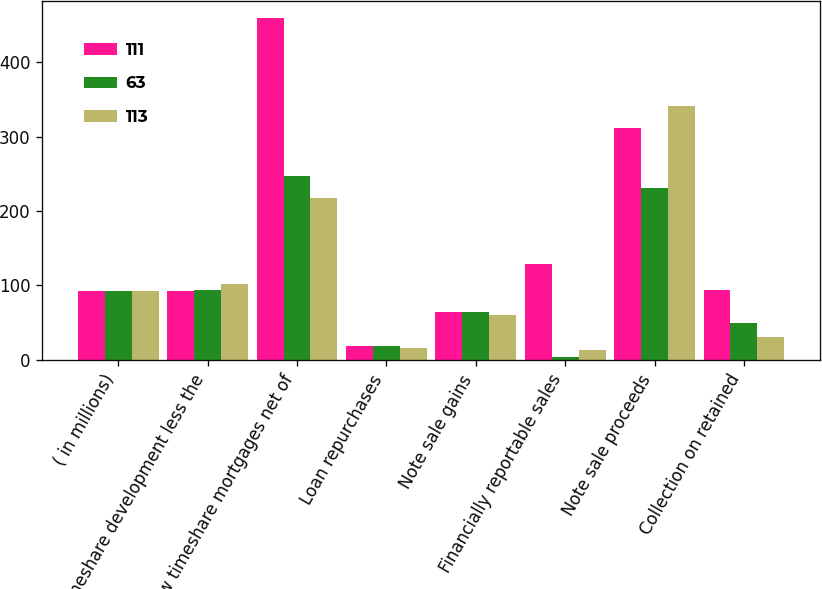Convert chart. <chart><loc_0><loc_0><loc_500><loc_500><stacked_bar_chart><ecel><fcel>( in millions)<fcel>Timeshare development less the<fcel>New timeshare mortgages net of<fcel>Loan repurchases<fcel>Note sale gains<fcel>Financially reportable sales<fcel>Note sale proceeds<fcel>Collection on retained<nl><fcel>111<fcel>93<fcel>93<fcel>459<fcel>18<fcel>64<fcel>129<fcel>312<fcel>94<nl><fcel>63<fcel>93<fcel>94<fcel>247<fcel>19<fcel>64<fcel>4<fcel>231<fcel>50<nl><fcel>113<fcel>93<fcel>102<fcel>218<fcel>16<fcel>60<fcel>13<fcel>341<fcel>31<nl></chart> 